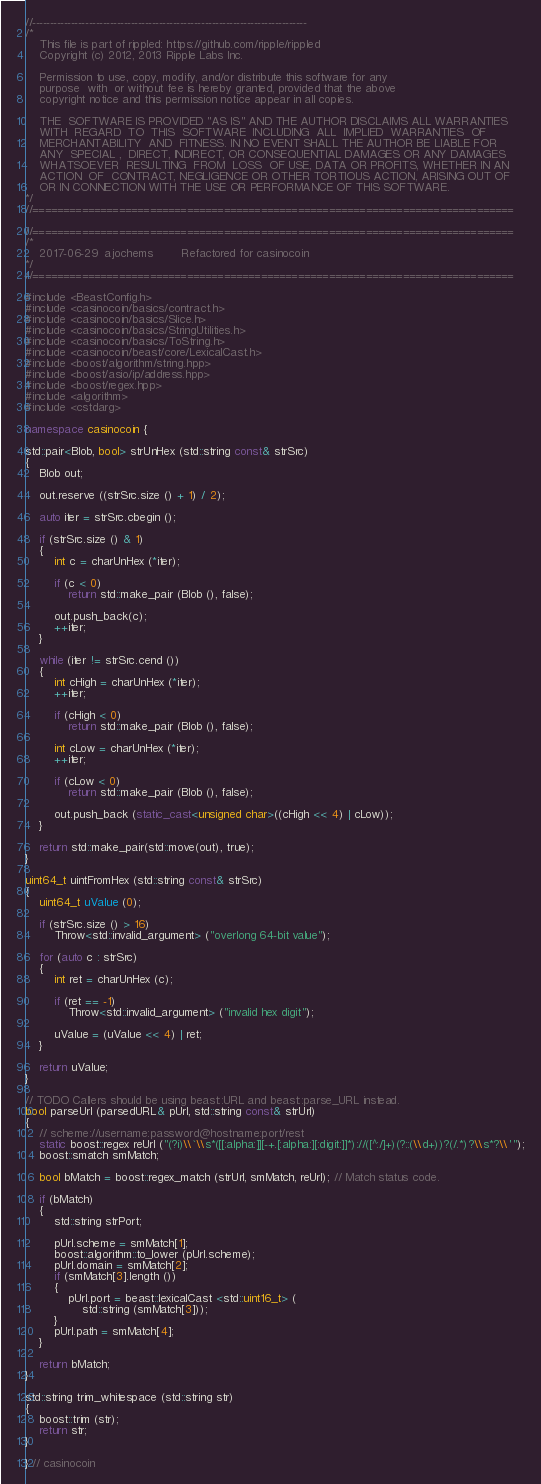<code> <loc_0><loc_0><loc_500><loc_500><_C++_>//------------------------------------------------------------------------------
/*
    This file is part of rippled: https://github.com/ripple/rippled
    Copyright (c) 2012, 2013 Ripple Labs Inc.

    Permission to use, copy, modify, and/or distribute this software for any
    purpose  with  or without fee is hereby granted, provided that the above
    copyright notice and this permission notice appear in all copies.

    THE  SOFTWARE IS PROVIDED "AS IS" AND THE AUTHOR DISCLAIMS ALL WARRANTIES
    WITH  REGARD  TO  THIS  SOFTWARE  INCLUDING  ALL  IMPLIED  WARRANTIES  OF
    MERCHANTABILITY  AND  FITNESS. IN NO EVENT SHALL THE AUTHOR BE LIABLE FOR
    ANY  SPECIAL ,  DIRECT, INDIRECT, OR CONSEQUENTIAL DAMAGES OR ANY DAMAGES
    WHATSOEVER  RESULTING  FROM  LOSS  OF USE, DATA OR PROFITS, WHETHER IN AN
    ACTION  OF  CONTRACT, NEGLIGENCE OR OTHER TORTIOUS ACTION, ARISING OUT OF
    OR IN CONNECTION WITH THE USE OR PERFORMANCE OF THIS SOFTWARE.
*/
//==============================================================================

//==============================================================================
/*
    2017-06-29  ajochems        Refactored for casinocoin
*/
//==============================================================================

#include <BeastConfig.h>
#include <casinocoin/basics/contract.h>
#include <casinocoin/basics/Slice.h>
#include <casinocoin/basics/StringUtilities.h>
#include <casinocoin/basics/ToString.h>
#include <casinocoin/beast/core/LexicalCast.h>
#include <boost/algorithm/string.hpp>
#include <boost/asio/ip/address.hpp>
#include <boost/regex.hpp>
#include <algorithm>
#include <cstdarg>

namespace casinocoin {

std::pair<Blob, bool> strUnHex (std::string const& strSrc)
{
    Blob out;

    out.reserve ((strSrc.size () + 1) / 2);

    auto iter = strSrc.cbegin ();

    if (strSrc.size () & 1)
    {
        int c = charUnHex (*iter);

        if (c < 0)
            return std::make_pair (Blob (), false);

        out.push_back(c);
        ++iter;
    }

    while (iter != strSrc.cend ())
    {
        int cHigh = charUnHex (*iter);
        ++iter;

        if (cHigh < 0)
            return std::make_pair (Blob (), false);

        int cLow = charUnHex (*iter);
        ++iter;

        if (cLow < 0)
            return std::make_pair (Blob (), false);

        out.push_back (static_cast<unsigned char>((cHigh << 4) | cLow));
    }

    return std::make_pair(std::move(out), true);
}

uint64_t uintFromHex (std::string const& strSrc)
{
    uint64_t uValue (0);

    if (strSrc.size () > 16)
        Throw<std::invalid_argument> ("overlong 64-bit value");

    for (auto c : strSrc)
    {
        int ret = charUnHex (c);

        if (ret == -1)
            Throw<std::invalid_argument> ("invalid hex digit");

        uValue = (uValue << 4) | ret;
    }

    return uValue;
}

// TODO Callers should be using beast::URL and beast::parse_URL instead.
bool parseUrl (parsedURL& pUrl, std::string const& strUrl)
{
    // scheme://username:password@hostname:port/rest
    static boost::regex reUrl ("(?i)\\`\\s*([[:alpha:]][-+.[:alpha:][:digit:]]*)://([^:/]+)(?::(\\d+))?(/.*)?\\s*?\\'");
    boost::smatch smMatch;

    bool bMatch = boost::regex_match (strUrl, smMatch, reUrl); // Match status code.

    if (bMatch)
    {
        std::string strPort;

        pUrl.scheme = smMatch[1];
        boost::algorithm::to_lower (pUrl.scheme);
        pUrl.domain = smMatch[2];
        if (smMatch[3].length ())
        {
            pUrl.port = beast::lexicalCast <std::uint16_t> (
                std::string (smMatch[3]));
        }
        pUrl.path = smMatch[4];
    }

    return bMatch;
}

std::string trim_whitespace (std::string str)
{
    boost::trim (str);
    return str;
}

} // casinocoin
</code> 